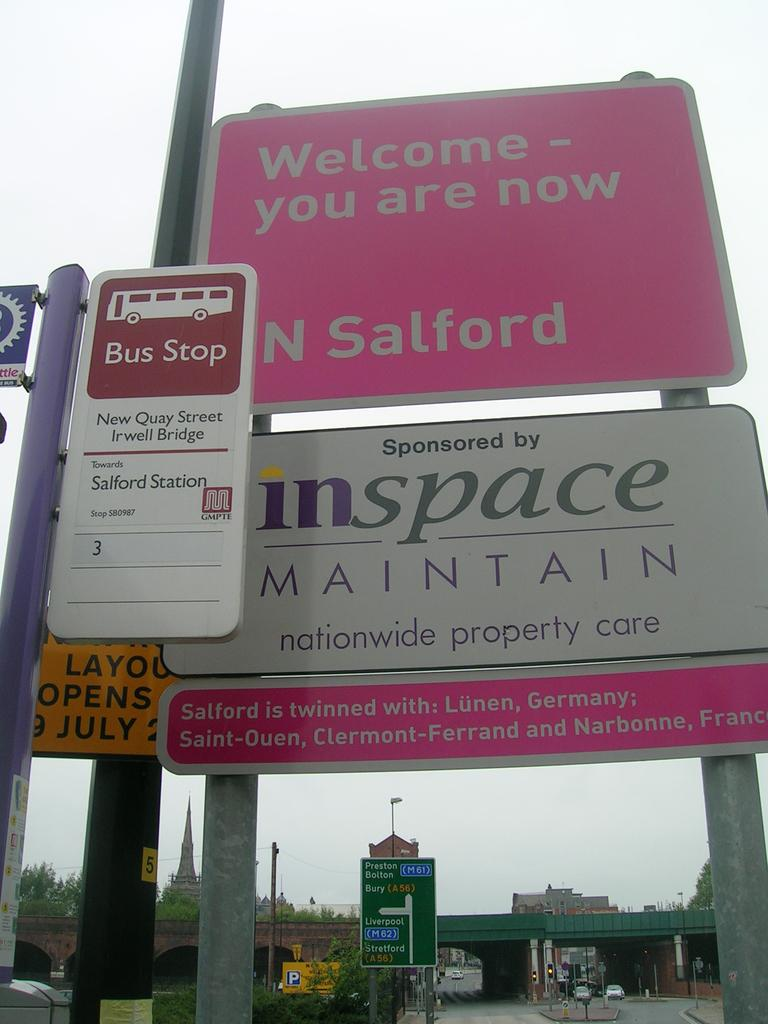<image>
Give a short and clear explanation of the subsequent image. A pink sign labeled you are now welcome 